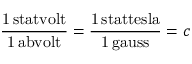Convert formula to latex. <formula><loc_0><loc_0><loc_500><loc_500>\frac { 1 \, s t a t v o l t } { 1 \, a b v o l t } = \frac { 1 \, s t a t t e s l a } { 1 \, g a u s s } = c</formula> 